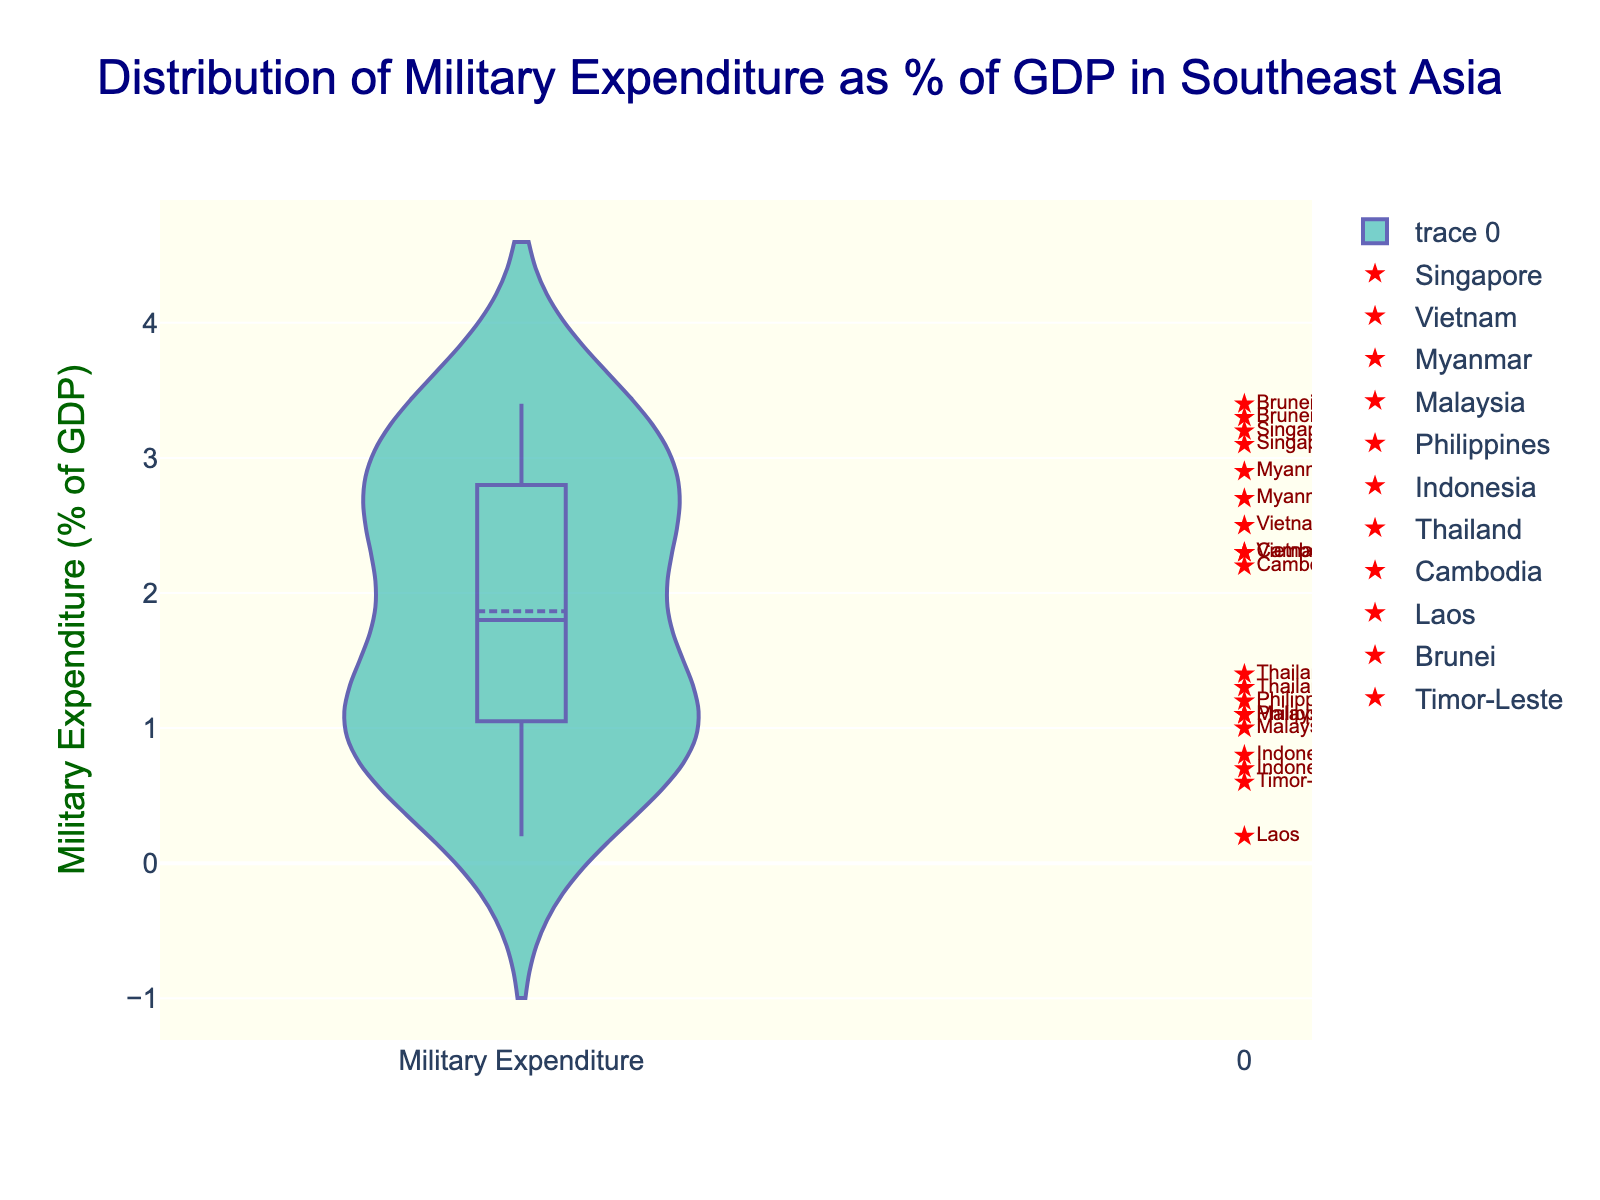What is the title of the plot? The title is usually prominently displayed at the top of the plot. In this plot, it can be found and it reads: "Distribution of Military Expenditure as % of GDP in Southeast Asia".
Answer: Distribution of Military Expenditure as % of GDP in Southeast Asia What is the y-axis title? The y-axis title is labeled clearly on the y-axis of the plot. In this figure, it is written as: "Military Expenditure (% of GDP)".
Answer: Military Expenditure (% of GDP) How many countries have data points above 3% of GDP? To find how many countries have their military expenditure above 3% of GDP, we look for markers that are positioned above the 3% line on the y-axis. The countries are Singapore and Brunei. Each has markers above this threshold.
Answer: 2 What is the range of military expenditure percentages in this plot? The range can be determined by identifying the minimum and maximum values on the y-axis. The lowest value is 0.2% and the highest is 3.4%. Therefore, the range is 3.4% - 0.2% = 3.2%.
Answer: 3.2% Which country has the highest military expenditure as a percentage of GDP? By scanning the plot visually for the highest data point on the y-axis, we see that Brunei has the highest value, at 3.4%.
Answer: Brunei How many data points are there for Vietnam? To determine how many data points there are for Vietnam, we count the number of markers labeled "Vietnam" in the plot. Vietnam has two markers at 2.3% and 2.5%.
Answer: 2 Which country has the lowest military expenditure as a percentage of GDP, and what is that value? The lowest military expenditure can be found by identifying the lowest data point on the y-axis. The country at this position is Laos, with a value of 0.2%.
Answer: Laos, 0.2% How do the military expenditures of Singapore and Indonesia compare? To compare Singapore and Indonesia, we locate their respective markers. Singapore's data points are at 3.2% and 3.1%, while Indonesia's are at 0.7% and 0.8%. Singapore's values are significantly higher than Indonesia's.
Answer: Singapore's expenditure is higher than Indonesia's What is the average military expenditure as a percentage of GDP for Thailand? To find the average for Thailand, we add its data points (1.4% and 1.3%) and divide by the number of points. (1.4 + 1.3) / 2 = 1.35%.
Answer: 1.35% Do any countries have data points that are equal to the mean line? We can determine whether any country’s data point is exactly at the mean line by visually comparing the mean line in the violin plot with the markers. Since the mean line is at approximately 1.75%, none of the markers exactly sit at this value.
Answer: No 